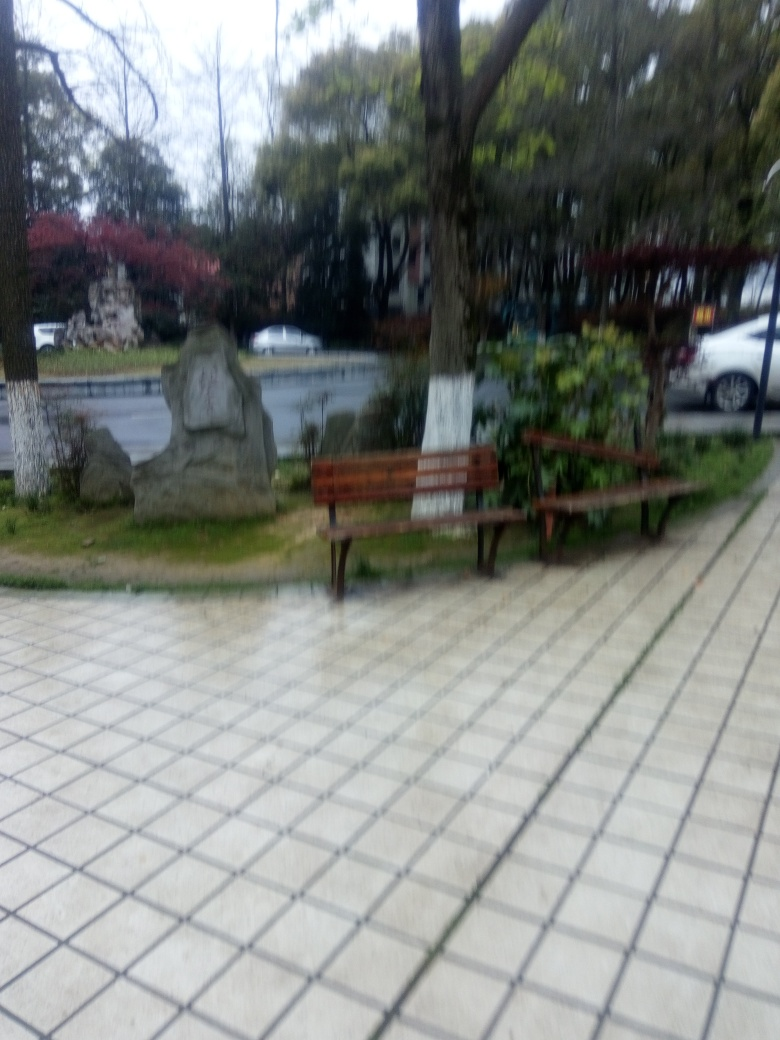Why is the image considered dim? The image appears dim due to the overcast conditions and the general lack of light possibly caused by the weather or the time of day. Additionally, the photograph could be underexposed, whether from camera settings or a low-quality camera sensor, which resulted in a darker output than what might be observed in person. 